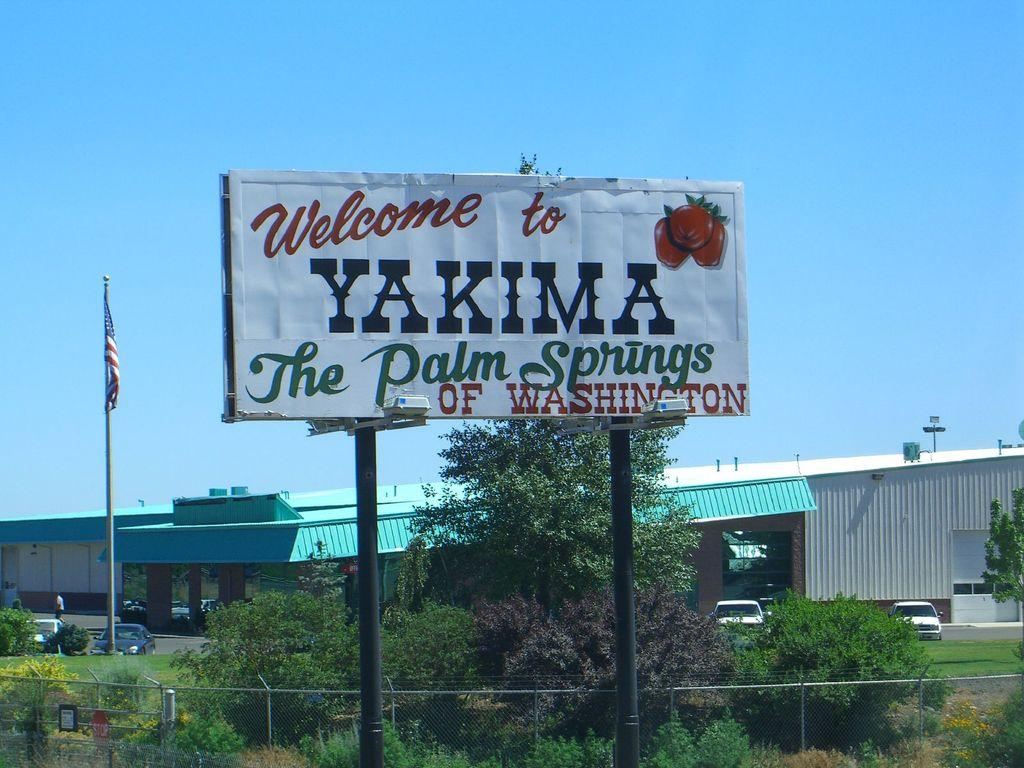<image>
Create a compact narrative representing the image presented. A billboard states that Yakima is the Palm Springs of Washington. 